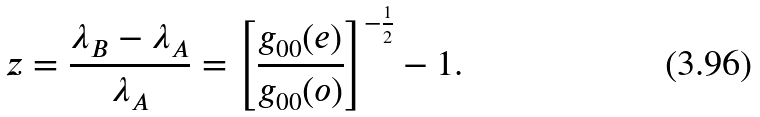Convert formula to latex. <formula><loc_0><loc_0><loc_500><loc_500>z = \frac { \lambda _ { B } - \lambda _ { A } } { \lambda _ { A } } = \left [ \frac { g _ { 0 0 } ( e ) } { g _ { 0 0 } ( o ) } \right ] ^ { - \frac { 1 } { 2 } } - 1 .</formula> 